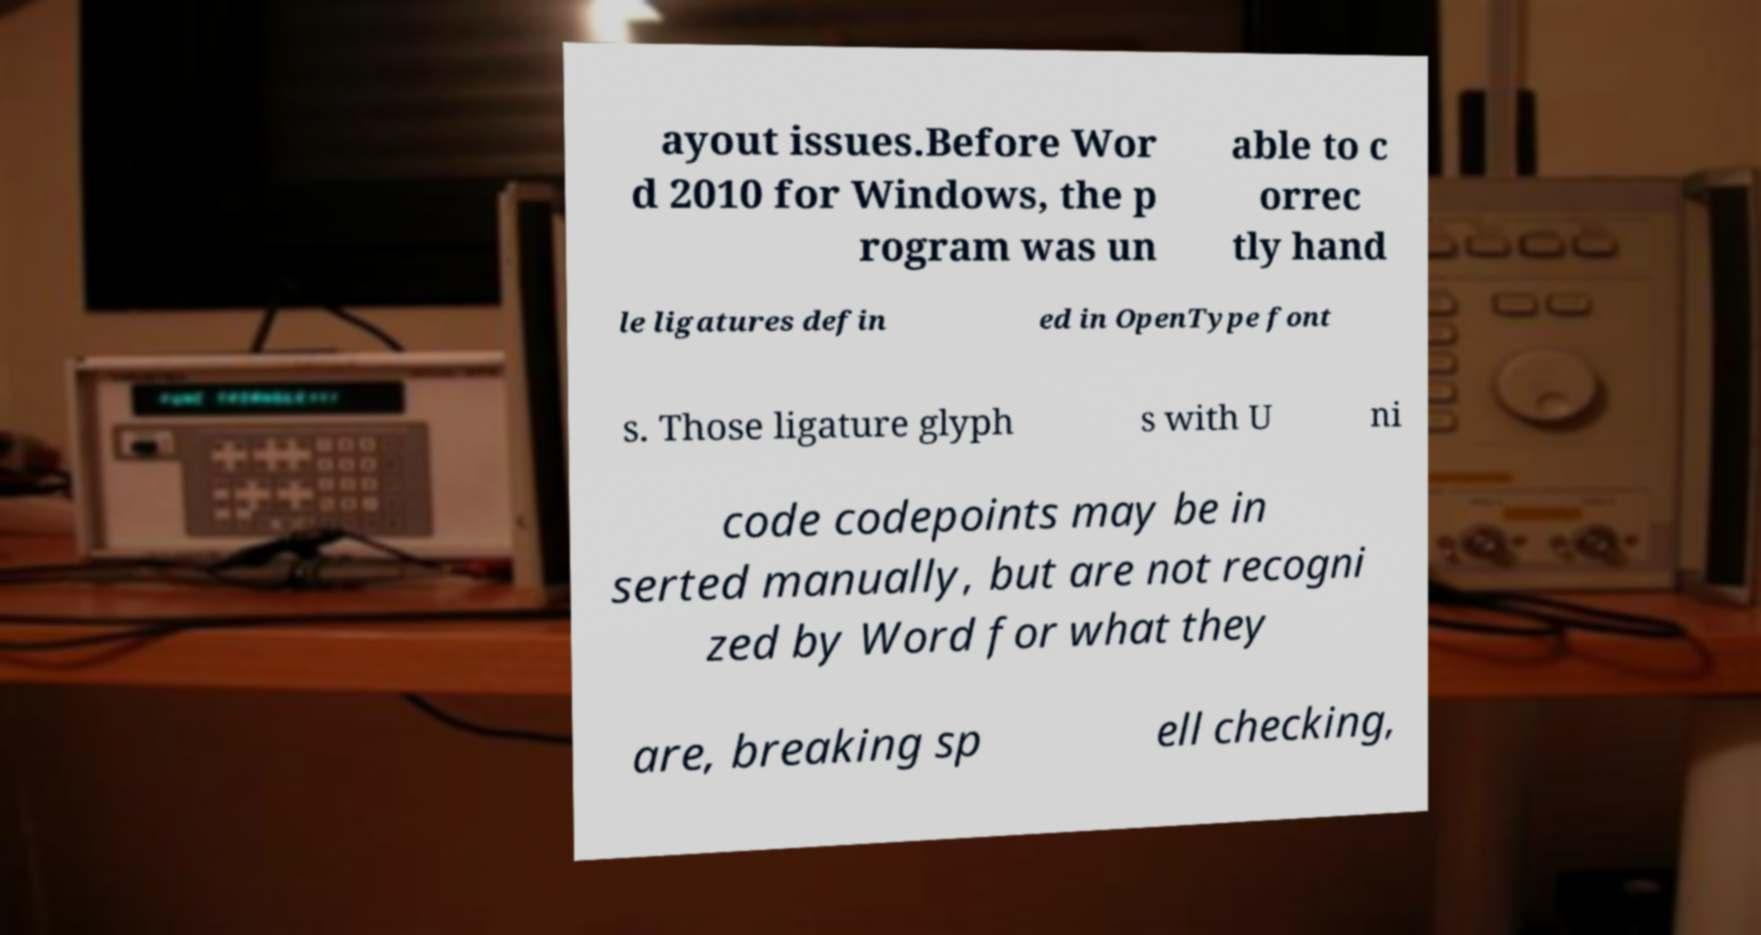Please read and relay the text visible in this image. What does it say? ayout issues.Before Wor d 2010 for Windows, the p rogram was un able to c orrec tly hand le ligatures defin ed in OpenType font s. Those ligature glyph s with U ni code codepoints may be in serted manually, but are not recogni zed by Word for what they are, breaking sp ell checking, 